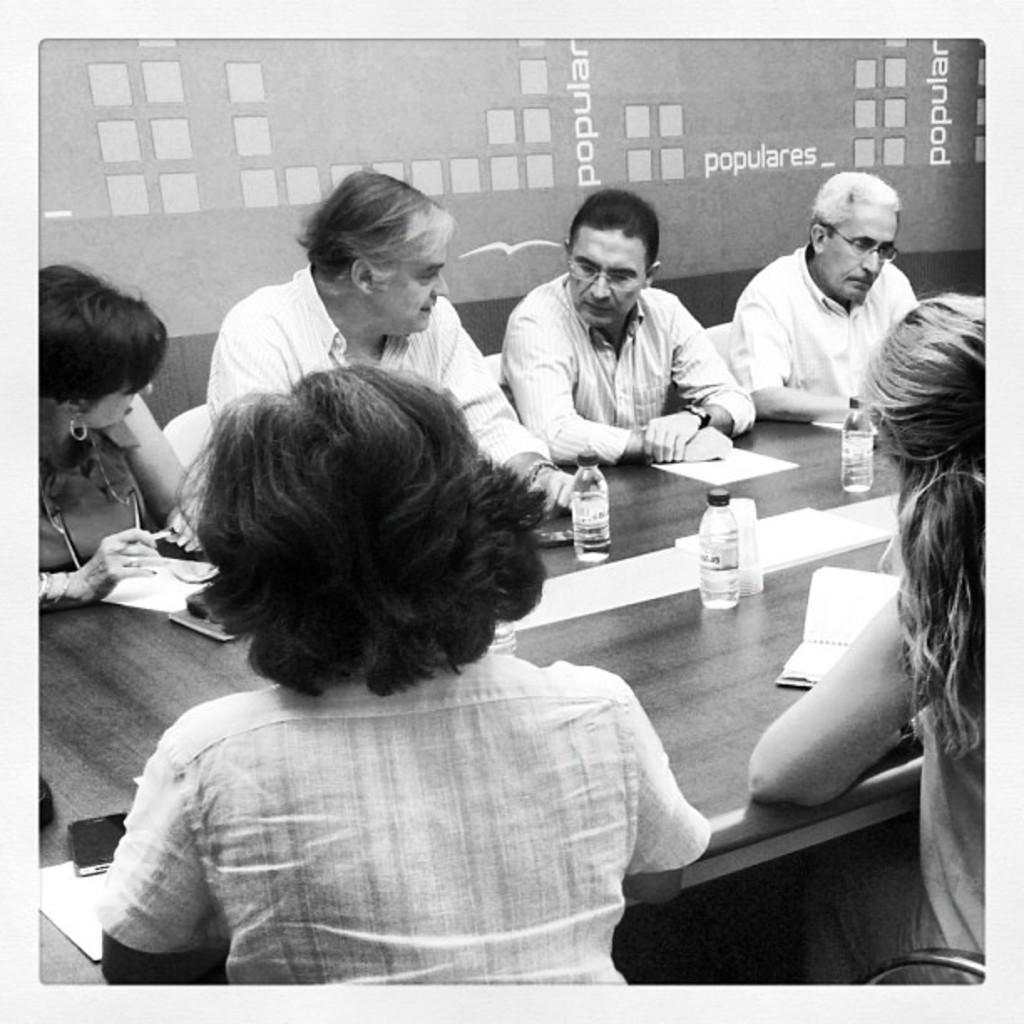How would you summarize this image in a sentence or two? This is a black and white picture. On the background we can see a board. Here we can see persons sitting on chairs in front of a table and discussing. On the table we can see papers, book, water bottles and also mobile. 